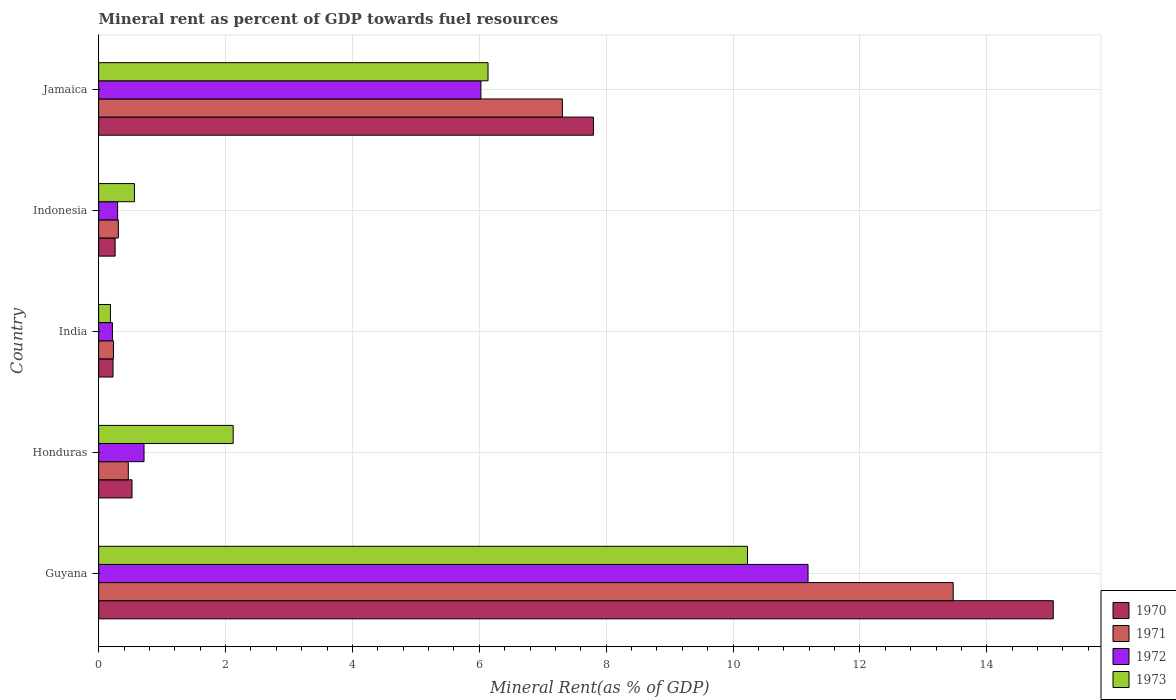Are the number of bars per tick equal to the number of legend labels?
Give a very brief answer. Yes. How many bars are there on the 1st tick from the bottom?
Your answer should be compact. 4. What is the label of the 3rd group of bars from the top?
Provide a short and direct response. India. What is the mineral rent in 1973 in Jamaica?
Provide a short and direct response. 6.14. Across all countries, what is the maximum mineral rent in 1972?
Make the answer very short. 11.18. Across all countries, what is the minimum mineral rent in 1970?
Ensure brevity in your answer.  0.23. In which country was the mineral rent in 1971 maximum?
Your answer should be very brief. Guyana. What is the total mineral rent in 1971 in the graph?
Your response must be concise. 21.79. What is the difference between the mineral rent in 1972 in Guyana and that in Indonesia?
Give a very brief answer. 10.88. What is the difference between the mineral rent in 1972 in India and the mineral rent in 1973 in Indonesia?
Your answer should be compact. -0.35. What is the average mineral rent in 1972 per country?
Give a very brief answer. 3.69. What is the difference between the mineral rent in 1970 and mineral rent in 1973 in Indonesia?
Provide a short and direct response. -0.3. In how many countries, is the mineral rent in 1971 greater than 12 %?
Provide a short and direct response. 1. What is the ratio of the mineral rent in 1973 in Guyana to that in Honduras?
Offer a terse response. 4.82. Is the difference between the mineral rent in 1970 in Guyana and Honduras greater than the difference between the mineral rent in 1973 in Guyana and Honduras?
Offer a terse response. Yes. What is the difference between the highest and the second highest mineral rent in 1971?
Your answer should be compact. 6.16. What is the difference between the highest and the lowest mineral rent in 1970?
Offer a very short reply. 14.82. Is the sum of the mineral rent in 1973 in Indonesia and Jamaica greater than the maximum mineral rent in 1971 across all countries?
Your answer should be very brief. No. Is it the case that in every country, the sum of the mineral rent in 1970 and mineral rent in 1973 is greater than the sum of mineral rent in 1972 and mineral rent in 1971?
Ensure brevity in your answer.  No. What does the 4th bar from the top in Honduras represents?
Offer a very short reply. 1970. What does the 1st bar from the bottom in Indonesia represents?
Make the answer very short. 1970. Is it the case that in every country, the sum of the mineral rent in 1970 and mineral rent in 1972 is greater than the mineral rent in 1971?
Your response must be concise. Yes. How many bars are there?
Make the answer very short. 20. Are all the bars in the graph horizontal?
Offer a terse response. Yes. How many countries are there in the graph?
Your response must be concise. 5. What is the difference between two consecutive major ticks on the X-axis?
Keep it short and to the point. 2. Does the graph contain grids?
Give a very brief answer. Yes. Where does the legend appear in the graph?
Ensure brevity in your answer.  Bottom right. What is the title of the graph?
Provide a short and direct response. Mineral rent as percent of GDP towards fuel resources. What is the label or title of the X-axis?
Your response must be concise. Mineral Rent(as % of GDP). What is the label or title of the Y-axis?
Your answer should be very brief. Country. What is the Mineral Rent(as % of GDP) in 1970 in Guyana?
Provide a short and direct response. 15.05. What is the Mineral Rent(as % of GDP) of 1971 in Guyana?
Make the answer very short. 13.47. What is the Mineral Rent(as % of GDP) in 1972 in Guyana?
Provide a succinct answer. 11.18. What is the Mineral Rent(as % of GDP) of 1973 in Guyana?
Provide a succinct answer. 10.23. What is the Mineral Rent(as % of GDP) in 1970 in Honduras?
Your response must be concise. 0.53. What is the Mineral Rent(as % of GDP) of 1971 in Honduras?
Give a very brief answer. 0.47. What is the Mineral Rent(as % of GDP) in 1972 in Honduras?
Your answer should be compact. 0.72. What is the Mineral Rent(as % of GDP) of 1973 in Honduras?
Offer a terse response. 2.12. What is the Mineral Rent(as % of GDP) in 1970 in India?
Give a very brief answer. 0.23. What is the Mineral Rent(as % of GDP) in 1971 in India?
Your response must be concise. 0.23. What is the Mineral Rent(as % of GDP) in 1972 in India?
Make the answer very short. 0.22. What is the Mineral Rent(as % of GDP) in 1973 in India?
Make the answer very short. 0.19. What is the Mineral Rent(as % of GDP) of 1970 in Indonesia?
Your response must be concise. 0.26. What is the Mineral Rent(as % of GDP) in 1971 in Indonesia?
Give a very brief answer. 0.31. What is the Mineral Rent(as % of GDP) in 1972 in Indonesia?
Give a very brief answer. 0.3. What is the Mineral Rent(as % of GDP) in 1973 in Indonesia?
Offer a terse response. 0.56. What is the Mineral Rent(as % of GDP) of 1970 in Jamaica?
Offer a very short reply. 7.8. What is the Mineral Rent(as % of GDP) in 1971 in Jamaica?
Your answer should be compact. 7.31. What is the Mineral Rent(as % of GDP) in 1972 in Jamaica?
Offer a very short reply. 6.03. What is the Mineral Rent(as % of GDP) in 1973 in Jamaica?
Make the answer very short. 6.14. Across all countries, what is the maximum Mineral Rent(as % of GDP) of 1970?
Your answer should be very brief. 15.05. Across all countries, what is the maximum Mineral Rent(as % of GDP) in 1971?
Provide a short and direct response. 13.47. Across all countries, what is the maximum Mineral Rent(as % of GDP) in 1972?
Your response must be concise. 11.18. Across all countries, what is the maximum Mineral Rent(as % of GDP) of 1973?
Offer a very short reply. 10.23. Across all countries, what is the minimum Mineral Rent(as % of GDP) in 1970?
Offer a terse response. 0.23. Across all countries, what is the minimum Mineral Rent(as % of GDP) of 1971?
Your answer should be very brief. 0.23. Across all countries, what is the minimum Mineral Rent(as % of GDP) in 1972?
Make the answer very short. 0.22. Across all countries, what is the minimum Mineral Rent(as % of GDP) of 1973?
Provide a succinct answer. 0.19. What is the total Mineral Rent(as % of GDP) in 1970 in the graph?
Keep it short and to the point. 23.86. What is the total Mineral Rent(as % of GDP) of 1971 in the graph?
Provide a succinct answer. 21.79. What is the total Mineral Rent(as % of GDP) in 1972 in the graph?
Ensure brevity in your answer.  18.44. What is the total Mineral Rent(as % of GDP) of 1973 in the graph?
Your response must be concise. 19.24. What is the difference between the Mineral Rent(as % of GDP) in 1970 in Guyana and that in Honduras?
Provide a short and direct response. 14.52. What is the difference between the Mineral Rent(as % of GDP) in 1971 in Guyana and that in Honduras?
Offer a very short reply. 13. What is the difference between the Mineral Rent(as % of GDP) of 1972 in Guyana and that in Honduras?
Offer a very short reply. 10.47. What is the difference between the Mineral Rent(as % of GDP) of 1973 in Guyana and that in Honduras?
Your answer should be very brief. 8.11. What is the difference between the Mineral Rent(as % of GDP) of 1970 in Guyana and that in India?
Offer a terse response. 14.82. What is the difference between the Mineral Rent(as % of GDP) of 1971 in Guyana and that in India?
Offer a very short reply. 13.24. What is the difference between the Mineral Rent(as % of GDP) of 1972 in Guyana and that in India?
Keep it short and to the point. 10.96. What is the difference between the Mineral Rent(as % of GDP) in 1973 in Guyana and that in India?
Your response must be concise. 10.04. What is the difference between the Mineral Rent(as % of GDP) of 1970 in Guyana and that in Indonesia?
Offer a terse response. 14.79. What is the difference between the Mineral Rent(as % of GDP) in 1971 in Guyana and that in Indonesia?
Offer a very short reply. 13.16. What is the difference between the Mineral Rent(as % of GDP) in 1972 in Guyana and that in Indonesia?
Your response must be concise. 10.88. What is the difference between the Mineral Rent(as % of GDP) in 1973 in Guyana and that in Indonesia?
Offer a very short reply. 9.66. What is the difference between the Mineral Rent(as % of GDP) of 1970 in Guyana and that in Jamaica?
Provide a short and direct response. 7.25. What is the difference between the Mineral Rent(as % of GDP) of 1971 in Guyana and that in Jamaica?
Offer a very short reply. 6.16. What is the difference between the Mineral Rent(as % of GDP) of 1972 in Guyana and that in Jamaica?
Your response must be concise. 5.16. What is the difference between the Mineral Rent(as % of GDP) of 1973 in Guyana and that in Jamaica?
Keep it short and to the point. 4.09. What is the difference between the Mineral Rent(as % of GDP) in 1970 in Honduras and that in India?
Keep it short and to the point. 0.3. What is the difference between the Mineral Rent(as % of GDP) in 1971 in Honduras and that in India?
Provide a short and direct response. 0.23. What is the difference between the Mineral Rent(as % of GDP) of 1972 in Honduras and that in India?
Give a very brief answer. 0.5. What is the difference between the Mineral Rent(as % of GDP) in 1973 in Honduras and that in India?
Your answer should be very brief. 1.94. What is the difference between the Mineral Rent(as % of GDP) in 1970 in Honduras and that in Indonesia?
Your answer should be compact. 0.27. What is the difference between the Mineral Rent(as % of GDP) of 1971 in Honduras and that in Indonesia?
Your response must be concise. 0.16. What is the difference between the Mineral Rent(as % of GDP) in 1972 in Honduras and that in Indonesia?
Your answer should be compact. 0.42. What is the difference between the Mineral Rent(as % of GDP) of 1973 in Honduras and that in Indonesia?
Give a very brief answer. 1.56. What is the difference between the Mineral Rent(as % of GDP) in 1970 in Honduras and that in Jamaica?
Your response must be concise. -7.27. What is the difference between the Mineral Rent(as % of GDP) of 1971 in Honduras and that in Jamaica?
Ensure brevity in your answer.  -6.84. What is the difference between the Mineral Rent(as % of GDP) in 1972 in Honduras and that in Jamaica?
Make the answer very short. -5.31. What is the difference between the Mineral Rent(as % of GDP) of 1973 in Honduras and that in Jamaica?
Your answer should be very brief. -4.02. What is the difference between the Mineral Rent(as % of GDP) in 1970 in India and that in Indonesia?
Offer a terse response. -0.03. What is the difference between the Mineral Rent(as % of GDP) of 1971 in India and that in Indonesia?
Your answer should be compact. -0.08. What is the difference between the Mineral Rent(as % of GDP) of 1972 in India and that in Indonesia?
Your answer should be very brief. -0.08. What is the difference between the Mineral Rent(as % of GDP) of 1973 in India and that in Indonesia?
Ensure brevity in your answer.  -0.38. What is the difference between the Mineral Rent(as % of GDP) in 1970 in India and that in Jamaica?
Your answer should be compact. -7.57. What is the difference between the Mineral Rent(as % of GDP) of 1971 in India and that in Jamaica?
Offer a very short reply. -7.08. What is the difference between the Mineral Rent(as % of GDP) in 1972 in India and that in Jamaica?
Keep it short and to the point. -5.81. What is the difference between the Mineral Rent(as % of GDP) in 1973 in India and that in Jamaica?
Offer a terse response. -5.95. What is the difference between the Mineral Rent(as % of GDP) of 1970 in Indonesia and that in Jamaica?
Offer a terse response. -7.54. What is the difference between the Mineral Rent(as % of GDP) in 1971 in Indonesia and that in Jamaica?
Make the answer very short. -7. What is the difference between the Mineral Rent(as % of GDP) of 1972 in Indonesia and that in Jamaica?
Provide a succinct answer. -5.73. What is the difference between the Mineral Rent(as % of GDP) in 1973 in Indonesia and that in Jamaica?
Give a very brief answer. -5.57. What is the difference between the Mineral Rent(as % of GDP) in 1970 in Guyana and the Mineral Rent(as % of GDP) in 1971 in Honduras?
Give a very brief answer. 14.58. What is the difference between the Mineral Rent(as % of GDP) in 1970 in Guyana and the Mineral Rent(as % of GDP) in 1972 in Honduras?
Your response must be concise. 14.33. What is the difference between the Mineral Rent(as % of GDP) in 1970 in Guyana and the Mineral Rent(as % of GDP) in 1973 in Honduras?
Keep it short and to the point. 12.93. What is the difference between the Mineral Rent(as % of GDP) of 1971 in Guyana and the Mineral Rent(as % of GDP) of 1972 in Honduras?
Your answer should be compact. 12.75. What is the difference between the Mineral Rent(as % of GDP) of 1971 in Guyana and the Mineral Rent(as % of GDP) of 1973 in Honduras?
Your response must be concise. 11.35. What is the difference between the Mineral Rent(as % of GDP) of 1972 in Guyana and the Mineral Rent(as % of GDP) of 1973 in Honduras?
Keep it short and to the point. 9.06. What is the difference between the Mineral Rent(as % of GDP) in 1970 in Guyana and the Mineral Rent(as % of GDP) in 1971 in India?
Provide a short and direct response. 14.81. What is the difference between the Mineral Rent(as % of GDP) in 1970 in Guyana and the Mineral Rent(as % of GDP) in 1972 in India?
Provide a short and direct response. 14.83. What is the difference between the Mineral Rent(as % of GDP) in 1970 in Guyana and the Mineral Rent(as % of GDP) in 1973 in India?
Ensure brevity in your answer.  14.86. What is the difference between the Mineral Rent(as % of GDP) in 1971 in Guyana and the Mineral Rent(as % of GDP) in 1972 in India?
Give a very brief answer. 13.25. What is the difference between the Mineral Rent(as % of GDP) of 1971 in Guyana and the Mineral Rent(as % of GDP) of 1973 in India?
Offer a very short reply. 13.28. What is the difference between the Mineral Rent(as % of GDP) in 1972 in Guyana and the Mineral Rent(as % of GDP) in 1973 in India?
Offer a terse response. 11. What is the difference between the Mineral Rent(as % of GDP) of 1970 in Guyana and the Mineral Rent(as % of GDP) of 1971 in Indonesia?
Offer a terse response. 14.74. What is the difference between the Mineral Rent(as % of GDP) in 1970 in Guyana and the Mineral Rent(as % of GDP) in 1972 in Indonesia?
Provide a short and direct response. 14.75. What is the difference between the Mineral Rent(as % of GDP) in 1970 in Guyana and the Mineral Rent(as % of GDP) in 1973 in Indonesia?
Keep it short and to the point. 14.48. What is the difference between the Mineral Rent(as % of GDP) in 1971 in Guyana and the Mineral Rent(as % of GDP) in 1972 in Indonesia?
Provide a short and direct response. 13.17. What is the difference between the Mineral Rent(as % of GDP) in 1971 in Guyana and the Mineral Rent(as % of GDP) in 1973 in Indonesia?
Your answer should be compact. 12.91. What is the difference between the Mineral Rent(as % of GDP) in 1972 in Guyana and the Mineral Rent(as % of GDP) in 1973 in Indonesia?
Offer a terse response. 10.62. What is the difference between the Mineral Rent(as % of GDP) in 1970 in Guyana and the Mineral Rent(as % of GDP) in 1971 in Jamaica?
Keep it short and to the point. 7.74. What is the difference between the Mineral Rent(as % of GDP) of 1970 in Guyana and the Mineral Rent(as % of GDP) of 1972 in Jamaica?
Make the answer very short. 9.02. What is the difference between the Mineral Rent(as % of GDP) of 1970 in Guyana and the Mineral Rent(as % of GDP) of 1973 in Jamaica?
Provide a succinct answer. 8.91. What is the difference between the Mineral Rent(as % of GDP) in 1971 in Guyana and the Mineral Rent(as % of GDP) in 1972 in Jamaica?
Provide a succinct answer. 7.44. What is the difference between the Mineral Rent(as % of GDP) of 1971 in Guyana and the Mineral Rent(as % of GDP) of 1973 in Jamaica?
Offer a terse response. 7.33. What is the difference between the Mineral Rent(as % of GDP) of 1972 in Guyana and the Mineral Rent(as % of GDP) of 1973 in Jamaica?
Keep it short and to the point. 5.04. What is the difference between the Mineral Rent(as % of GDP) in 1970 in Honduras and the Mineral Rent(as % of GDP) in 1971 in India?
Your answer should be very brief. 0.29. What is the difference between the Mineral Rent(as % of GDP) of 1970 in Honduras and the Mineral Rent(as % of GDP) of 1972 in India?
Provide a succinct answer. 0.31. What is the difference between the Mineral Rent(as % of GDP) in 1970 in Honduras and the Mineral Rent(as % of GDP) in 1973 in India?
Offer a very short reply. 0.34. What is the difference between the Mineral Rent(as % of GDP) of 1971 in Honduras and the Mineral Rent(as % of GDP) of 1972 in India?
Your answer should be very brief. 0.25. What is the difference between the Mineral Rent(as % of GDP) in 1971 in Honduras and the Mineral Rent(as % of GDP) in 1973 in India?
Your answer should be very brief. 0.28. What is the difference between the Mineral Rent(as % of GDP) of 1972 in Honduras and the Mineral Rent(as % of GDP) of 1973 in India?
Ensure brevity in your answer.  0.53. What is the difference between the Mineral Rent(as % of GDP) of 1970 in Honduras and the Mineral Rent(as % of GDP) of 1971 in Indonesia?
Offer a very short reply. 0.22. What is the difference between the Mineral Rent(as % of GDP) in 1970 in Honduras and the Mineral Rent(as % of GDP) in 1972 in Indonesia?
Offer a very short reply. 0.23. What is the difference between the Mineral Rent(as % of GDP) in 1970 in Honduras and the Mineral Rent(as % of GDP) in 1973 in Indonesia?
Keep it short and to the point. -0.04. What is the difference between the Mineral Rent(as % of GDP) of 1971 in Honduras and the Mineral Rent(as % of GDP) of 1972 in Indonesia?
Provide a short and direct response. 0.17. What is the difference between the Mineral Rent(as % of GDP) of 1971 in Honduras and the Mineral Rent(as % of GDP) of 1973 in Indonesia?
Ensure brevity in your answer.  -0.1. What is the difference between the Mineral Rent(as % of GDP) of 1972 in Honduras and the Mineral Rent(as % of GDP) of 1973 in Indonesia?
Ensure brevity in your answer.  0.15. What is the difference between the Mineral Rent(as % of GDP) of 1970 in Honduras and the Mineral Rent(as % of GDP) of 1971 in Jamaica?
Provide a succinct answer. -6.78. What is the difference between the Mineral Rent(as % of GDP) of 1970 in Honduras and the Mineral Rent(as % of GDP) of 1972 in Jamaica?
Provide a short and direct response. -5.5. What is the difference between the Mineral Rent(as % of GDP) in 1970 in Honduras and the Mineral Rent(as % of GDP) in 1973 in Jamaica?
Make the answer very short. -5.61. What is the difference between the Mineral Rent(as % of GDP) in 1971 in Honduras and the Mineral Rent(as % of GDP) in 1972 in Jamaica?
Your answer should be compact. -5.56. What is the difference between the Mineral Rent(as % of GDP) of 1971 in Honduras and the Mineral Rent(as % of GDP) of 1973 in Jamaica?
Provide a succinct answer. -5.67. What is the difference between the Mineral Rent(as % of GDP) in 1972 in Honduras and the Mineral Rent(as % of GDP) in 1973 in Jamaica?
Provide a succinct answer. -5.42. What is the difference between the Mineral Rent(as % of GDP) in 1970 in India and the Mineral Rent(as % of GDP) in 1971 in Indonesia?
Keep it short and to the point. -0.08. What is the difference between the Mineral Rent(as % of GDP) of 1970 in India and the Mineral Rent(as % of GDP) of 1972 in Indonesia?
Ensure brevity in your answer.  -0.07. What is the difference between the Mineral Rent(as % of GDP) of 1970 in India and the Mineral Rent(as % of GDP) of 1973 in Indonesia?
Offer a very short reply. -0.34. What is the difference between the Mineral Rent(as % of GDP) in 1971 in India and the Mineral Rent(as % of GDP) in 1972 in Indonesia?
Keep it short and to the point. -0.07. What is the difference between the Mineral Rent(as % of GDP) of 1971 in India and the Mineral Rent(as % of GDP) of 1973 in Indonesia?
Your response must be concise. -0.33. What is the difference between the Mineral Rent(as % of GDP) in 1972 in India and the Mineral Rent(as % of GDP) in 1973 in Indonesia?
Make the answer very short. -0.35. What is the difference between the Mineral Rent(as % of GDP) in 1970 in India and the Mineral Rent(as % of GDP) in 1971 in Jamaica?
Give a very brief answer. -7.08. What is the difference between the Mineral Rent(as % of GDP) in 1970 in India and the Mineral Rent(as % of GDP) in 1972 in Jamaica?
Your answer should be very brief. -5.8. What is the difference between the Mineral Rent(as % of GDP) in 1970 in India and the Mineral Rent(as % of GDP) in 1973 in Jamaica?
Offer a very short reply. -5.91. What is the difference between the Mineral Rent(as % of GDP) of 1971 in India and the Mineral Rent(as % of GDP) of 1972 in Jamaica?
Provide a short and direct response. -5.79. What is the difference between the Mineral Rent(as % of GDP) of 1971 in India and the Mineral Rent(as % of GDP) of 1973 in Jamaica?
Provide a succinct answer. -5.9. What is the difference between the Mineral Rent(as % of GDP) of 1972 in India and the Mineral Rent(as % of GDP) of 1973 in Jamaica?
Keep it short and to the point. -5.92. What is the difference between the Mineral Rent(as % of GDP) in 1970 in Indonesia and the Mineral Rent(as % of GDP) in 1971 in Jamaica?
Ensure brevity in your answer.  -7.05. What is the difference between the Mineral Rent(as % of GDP) in 1970 in Indonesia and the Mineral Rent(as % of GDP) in 1972 in Jamaica?
Provide a succinct answer. -5.77. What is the difference between the Mineral Rent(as % of GDP) of 1970 in Indonesia and the Mineral Rent(as % of GDP) of 1973 in Jamaica?
Ensure brevity in your answer.  -5.88. What is the difference between the Mineral Rent(as % of GDP) of 1971 in Indonesia and the Mineral Rent(as % of GDP) of 1972 in Jamaica?
Your answer should be compact. -5.72. What is the difference between the Mineral Rent(as % of GDP) of 1971 in Indonesia and the Mineral Rent(as % of GDP) of 1973 in Jamaica?
Offer a very short reply. -5.83. What is the difference between the Mineral Rent(as % of GDP) in 1972 in Indonesia and the Mineral Rent(as % of GDP) in 1973 in Jamaica?
Provide a short and direct response. -5.84. What is the average Mineral Rent(as % of GDP) in 1970 per country?
Your response must be concise. 4.77. What is the average Mineral Rent(as % of GDP) in 1971 per country?
Your answer should be compact. 4.36. What is the average Mineral Rent(as % of GDP) in 1972 per country?
Offer a terse response. 3.69. What is the average Mineral Rent(as % of GDP) of 1973 per country?
Your answer should be compact. 3.85. What is the difference between the Mineral Rent(as % of GDP) in 1970 and Mineral Rent(as % of GDP) in 1971 in Guyana?
Your answer should be very brief. 1.58. What is the difference between the Mineral Rent(as % of GDP) in 1970 and Mineral Rent(as % of GDP) in 1972 in Guyana?
Provide a succinct answer. 3.87. What is the difference between the Mineral Rent(as % of GDP) in 1970 and Mineral Rent(as % of GDP) in 1973 in Guyana?
Ensure brevity in your answer.  4.82. What is the difference between the Mineral Rent(as % of GDP) in 1971 and Mineral Rent(as % of GDP) in 1972 in Guyana?
Give a very brief answer. 2.29. What is the difference between the Mineral Rent(as % of GDP) of 1971 and Mineral Rent(as % of GDP) of 1973 in Guyana?
Give a very brief answer. 3.24. What is the difference between the Mineral Rent(as % of GDP) of 1972 and Mineral Rent(as % of GDP) of 1973 in Guyana?
Your answer should be compact. 0.95. What is the difference between the Mineral Rent(as % of GDP) in 1970 and Mineral Rent(as % of GDP) in 1971 in Honduras?
Offer a very short reply. 0.06. What is the difference between the Mineral Rent(as % of GDP) of 1970 and Mineral Rent(as % of GDP) of 1972 in Honduras?
Give a very brief answer. -0.19. What is the difference between the Mineral Rent(as % of GDP) of 1970 and Mineral Rent(as % of GDP) of 1973 in Honduras?
Offer a terse response. -1.59. What is the difference between the Mineral Rent(as % of GDP) of 1971 and Mineral Rent(as % of GDP) of 1972 in Honduras?
Your answer should be compact. -0.25. What is the difference between the Mineral Rent(as % of GDP) of 1971 and Mineral Rent(as % of GDP) of 1973 in Honduras?
Provide a short and direct response. -1.65. What is the difference between the Mineral Rent(as % of GDP) in 1972 and Mineral Rent(as % of GDP) in 1973 in Honduras?
Your response must be concise. -1.41. What is the difference between the Mineral Rent(as % of GDP) of 1970 and Mineral Rent(as % of GDP) of 1971 in India?
Provide a succinct answer. -0.01. What is the difference between the Mineral Rent(as % of GDP) of 1970 and Mineral Rent(as % of GDP) of 1972 in India?
Ensure brevity in your answer.  0.01. What is the difference between the Mineral Rent(as % of GDP) of 1970 and Mineral Rent(as % of GDP) of 1973 in India?
Your response must be concise. 0.04. What is the difference between the Mineral Rent(as % of GDP) in 1971 and Mineral Rent(as % of GDP) in 1972 in India?
Ensure brevity in your answer.  0.02. What is the difference between the Mineral Rent(as % of GDP) in 1971 and Mineral Rent(as % of GDP) in 1973 in India?
Your response must be concise. 0.05. What is the difference between the Mineral Rent(as % of GDP) of 1972 and Mineral Rent(as % of GDP) of 1973 in India?
Your response must be concise. 0.03. What is the difference between the Mineral Rent(as % of GDP) in 1970 and Mineral Rent(as % of GDP) in 1971 in Indonesia?
Give a very brief answer. -0.05. What is the difference between the Mineral Rent(as % of GDP) in 1970 and Mineral Rent(as % of GDP) in 1972 in Indonesia?
Give a very brief answer. -0.04. What is the difference between the Mineral Rent(as % of GDP) of 1970 and Mineral Rent(as % of GDP) of 1973 in Indonesia?
Offer a very short reply. -0.3. What is the difference between the Mineral Rent(as % of GDP) of 1971 and Mineral Rent(as % of GDP) of 1972 in Indonesia?
Your answer should be very brief. 0.01. What is the difference between the Mineral Rent(as % of GDP) of 1971 and Mineral Rent(as % of GDP) of 1973 in Indonesia?
Provide a short and direct response. -0.25. What is the difference between the Mineral Rent(as % of GDP) of 1972 and Mineral Rent(as % of GDP) of 1973 in Indonesia?
Give a very brief answer. -0.27. What is the difference between the Mineral Rent(as % of GDP) in 1970 and Mineral Rent(as % of GDP) in 1971 in Jamaica?
Provide a short and direct response. 0.49. What is the difference between the Mineral Rent(as % of GDP) in 1970 and Mineral Rent(as % of GDP) in 1972 in Jamaica?
Keep it short and to the point. 1.77. What is the difference between the Mineral Rent(as % of GDP) of 1970 and Mineral Rent(as % of GDP) of 1973 in Jamaica?
Your answer should be very brief. 1.66. What is the difference between the Mineral Rent(as % of GDP) of 1971 and Mineral Rent(as % of GDP) of 1972 in Jamaica?
Provide a succinct answer. 1.28. What is the difference between the Mineral Rent(as % of GDP) of 1971 and Mineral Rent(as % of GDP) of 1973 in Jamaica?
Offer a terse response. 1.17. What is the difference between the Mineral Rent(as % of GDP) of 1972 and Mineral Rent(as % of GDP) of 1973 in Jamaica?
Provide a succinct answer. -0.11. What is the ratio of the Mineral Rent(as % of GDP) of 1970 in Guyana to that in Honduras?
Offer a terse response. 28.59. What is the ratio of the Mineral Rent(as % of GDP) in 1971 in Guyana to that in Honduras?
Your response must be concise. 28.82. What is the ratio of the Mineral Rent(as % of GDP) of 1972 in Guyana to that in Honduras?
Offer a very short reply. 15.63. What is the ratio of the Mineral Rent(as % of GDP) in 1973 in Guyana to that in Honduras?
Offer a very short reply. 4.82. What is the ratio of the Mineral Rent(as % of GDP) in 1970 in Guyana to that in India?
Make the answer very short. 66.33. What is the ratio of the Mineral Rent(as % of GDP) of 1971 in Guyana to that in India?
Keep it short and to the point. 57.65. What is the ratio of the Mineral Rent(as % of GDP) in 1972 in Guyana to that in India?
Your answer should be compact. 51.44. What is the ratio of the Mineral Rent(as % of GDP) of 1973 in Guyana to that in India?
Your answer should be compact. 55. What is the ratio of the Mineral Rent(as % of GDP) of 1970 in Guyana to that in Indonesia?
Your response must be concise. 57.85. What is the ratio of the Mineral Rent(as % of GDP) of 1971 in Guyana to that in Indonesia?
Keep it short and to the point. 43.38. What is the ratio of the Mineral Rent(as % of GDP) in 1972 in Guyana to that in Indonesia?
Your answer should be compact. 37.44. What is the ratio of the Mineral Rent(as % of GDP) of 1973 in Guyana to that in Indonesia?
Offer a terse response. 18.12. What is the ratio of the Mineral Rent(as % of GDP) of 1970 in Guyana to that in Jamaica?
Ensure brevity in your answer.  1.93. What is the ratio of the Mineral Rent(as % of GDP) of 1971 in Guyana to that in Jamaica?
Ensure brevity in your answer.  1.84. What is the ratio of the Mineral Rent(as % of GDP) of 1972 in Guyana to that in Jamaica?
Offer a terse response. 1.86. What is the ratio of the Mineral Rent(as % of GDP) in 1973 in Guyana to that in Jamaica?
Your answer should be compact. 1.67. What is the ratio of the Mineral Rent(as % of GDP) of 1970 in Honduras to that in India?
Offer a very short reply. 2.32. What is the ratio of the Mineral Rent(as % of GDP) of 1971 in Honduras to that in India?
Offer a terse response. 2. What is the ratio of the Mineral Rent(as % of GDP) in 1972 in Honduras to that in India?
Your answer should be compact. 3.29. What is the ratio of the Mineral Rent(as % of GDP) of 1973 in Honduras to that in India?
Your response must be concise. 11.41. What is the ratio of the Mineral Rent(as % of GDP) of 1970 in Honduras to that in Indonesia?
Your response must be concise. 2.02. What is the ratio of the Mineral Rent(as % of GDP) of 1971 in Honduras to that in Indonesia?
Your response must be concise. 1.51. What is the ratio of the Mineral Rent(as % of GDP) of 1972 in Honduras to that in Indonesia?
Offer a terse response. 2.4. What is the ratio of the Mineral Rent(as % of GDP) in 1973 in Honduras to that in Indonesia?
Your answer should be compact. 3.76. What is the ratio of the Mineral Rent(as % of GDP) in 1970 in Honduras to that in Jamaica?
Give a very brief answer. 0.07. What is the ratio of the Mineral Rent(as % of GDP) of 1971 in Honduras to that in Jamaica?
Keep it short and to the point. 0.06. What is the ratio of the Mineral Rent(as % of GDP) of 1972 in Honduras to that in Jamaica?
Your answer should be compact. 0.12. What is the ratio of the Mineral Rent(as % of GDP) of 1973 in Honduras to that in Jamaica?
Give a very brief answer. 0.35. What is the ratio of the Mineral Rent(as % of GDP) of 1970 in India to that in Indonesia?
Offer a terse response. 0.87. What is the ratio of the Mineral Rent(as % of GDP) of 1971 in India to that in Indonesia?
Offer a very short reply. 0.75. What is the ratio of the Mineral Rent(as % of GDP) in 1972 in India to that in Indonesia?
Offer a terse response. 0.73. What is the ratio of the Mineral Rent(as % of GDP) of 1973 in India to that in Indonesia?
Make the answer very short. 0.33. What is the ratio of the Mineral Rent(as % of GDP) of 1970 in India to that in Jamaica?
Your answer should be very brief. 0.03. What is the ratio of the Mineral Rent(as % of GDP) of 1971 in India to that in Jamaica?
Offer a very short reply. 0.03. What is the ratio of the Mineral Rent(as % of GDP) of 1972 in India to that in Jamaica?
Provide a succinct answer. 0.04. What is the ratio of the Mineral Rent(as % of GDP) in 1973 in India to that in Jamaica?
Provide a short and direct response. 0.03. What is the ratio of the Mineral Rent(as % of GDP) in 1970 in Indonesia to that in Jamaica?
Your response must be concise. 0.03. What is the ratio of the Mineral Rent(as % of GDP) in 1971 in Indonesia to that in Jamaica?
Your answer should be very brief. 0.04. What is the ratio of the Mineral Rent(as % of GDP) of 1972 in Indonesia to that in Jamaica?
Give a very brief answer. 0.05. What is the ratio of the Mineral Rent(as % of GDP) in 1973 in Indonesia to that in Jamaica?
Ensure brevity in your answer.  0.09. What is the difference between the highest and the second highest Mineral Rent(as % of GDP) of 1970?
Offer a very short reply. 7.25. What is the difference between the highest and the second highest Mineral Rent(as % of GDP) of 1971?
Provide a short and direct response. 6.16. What is the difference between the highest and the second highest Mineral Rent(as % of GDP) in 1972?
Offer a very short reply. 5.16. What is the difference between the highest and the second highest Mineral Rent(as % of GDP) of 1973?
Offer a very short reply. 4.09. What is the difference between the highest and the lowest Mineral Rent(as % of GDP) of 1970?
Offer a terse response. 14.82. What is the difference between the highest and the lowest Mineral Rent(as % of GDP) in 1971?
Your answer should be compact. 13.24. What is the difference between the highest and the lowest Mineral Rent(as % of GDP) in 1972?
Your answer should be very brief. 10.96. What is the difference between the highest and the lowest Mineral Rent(as % of GDP) in 1973?
Make the answer very short. 10.04. 